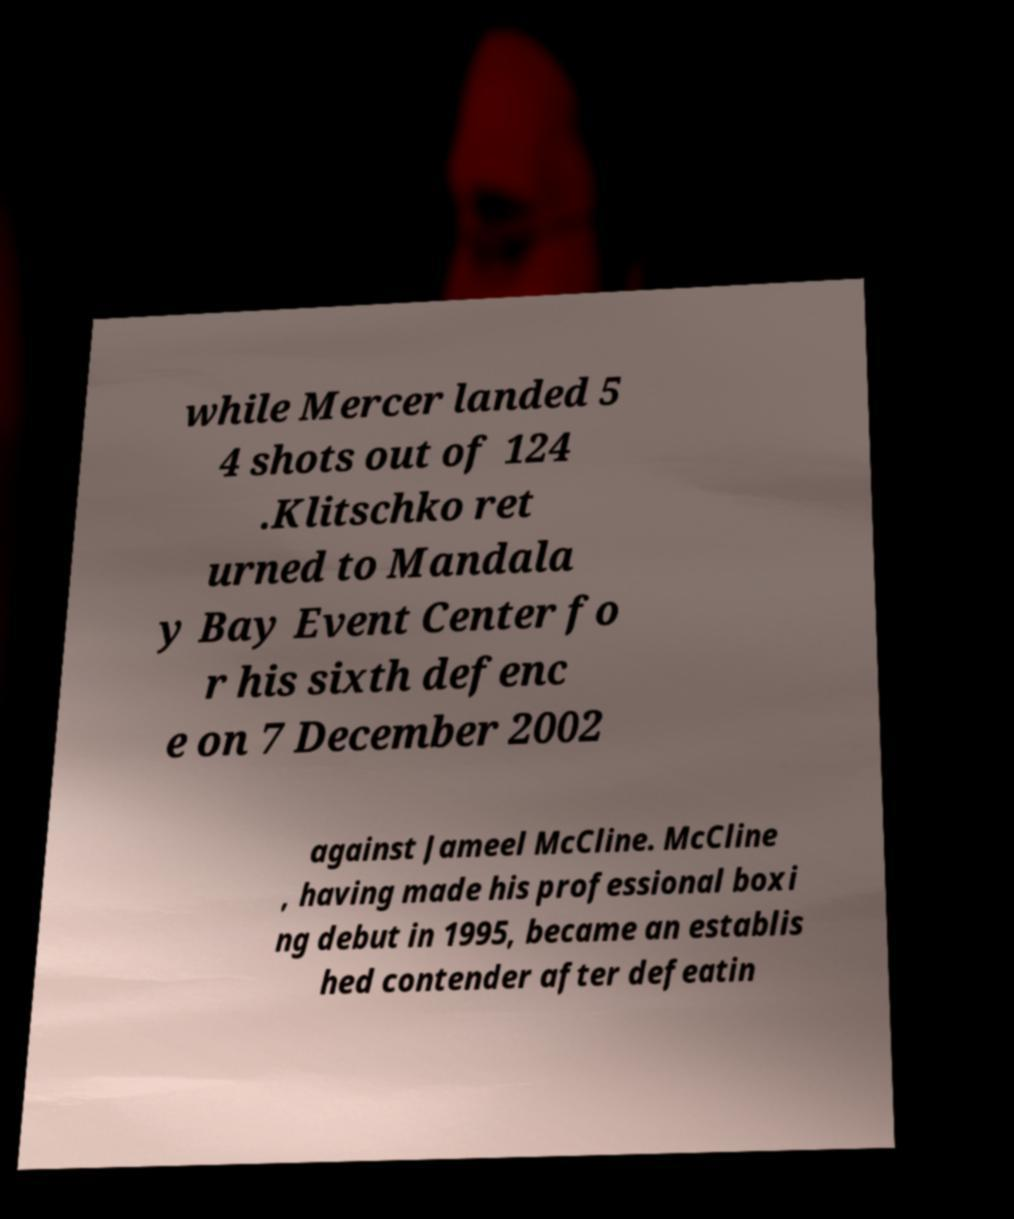Can you accurately transcribe the text from the provided image for me? while Mercer landed 5 4 shots out of 124 .Klitschko ret urned to Mandala y Bay Event Center fo r his sixth defenc e on 7 December 2002 against Jameel McCline. McCline , having made his professional boxi ng debut in 1995, became an establis hed contender after defeatin 